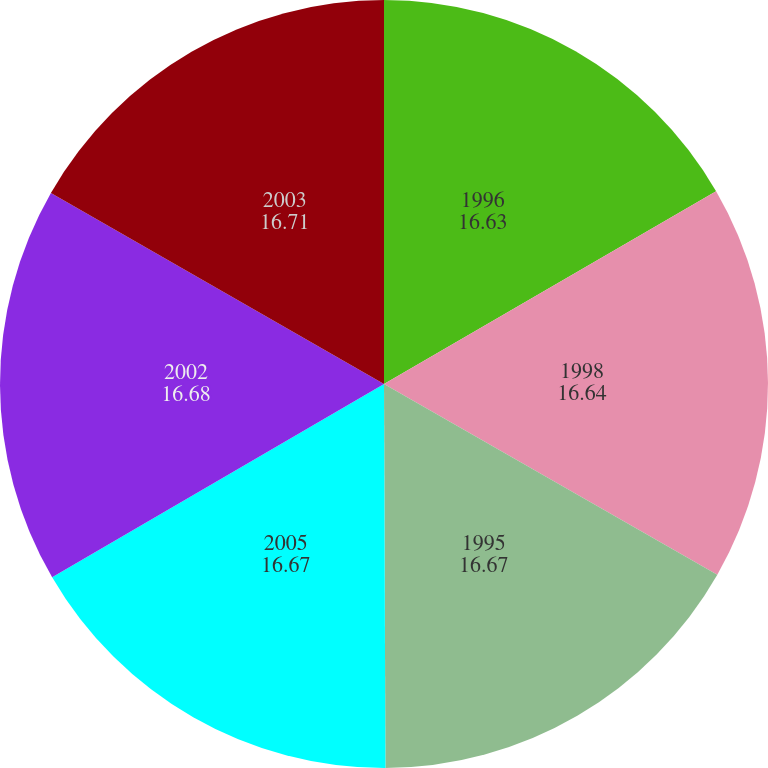Convert chart to OTSL. <chart><loc_0><loc_0><loc_500><loc_500><pie_chart><fcel>1996<fcel>1998<fcel>1995<fcel>2005<fcel>2002<fcel>2003<nl><fcel>16.63%<fcel>16.64%<fcel>16.67%<fcel>16.67%<fcel>16.68%<fcel>16.71%<nl></chart> 